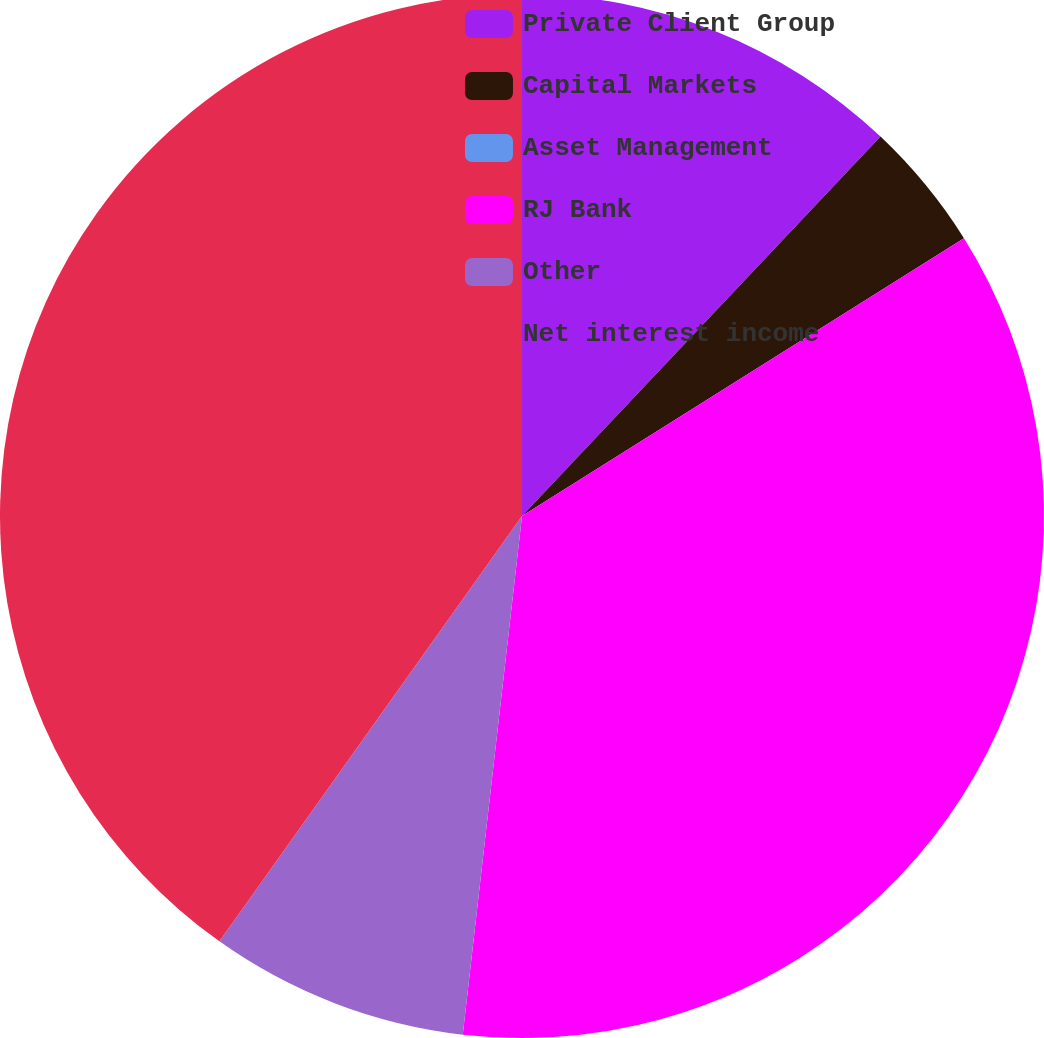<chart> <loc_0><loc_0><loc_500><loc_500><pie_chart><fcel>Private Client Group<fcel>Capital Markets<fcel>Asset Management<fcel>RJ Bank<fcel>Other<fcel>Net interest income<nl><fcel>12.05%<fcel>4.02%<fcel>0.0%<fcel>35.74%<fcel>8.03%<fcel>40.16%<nl></chart> 